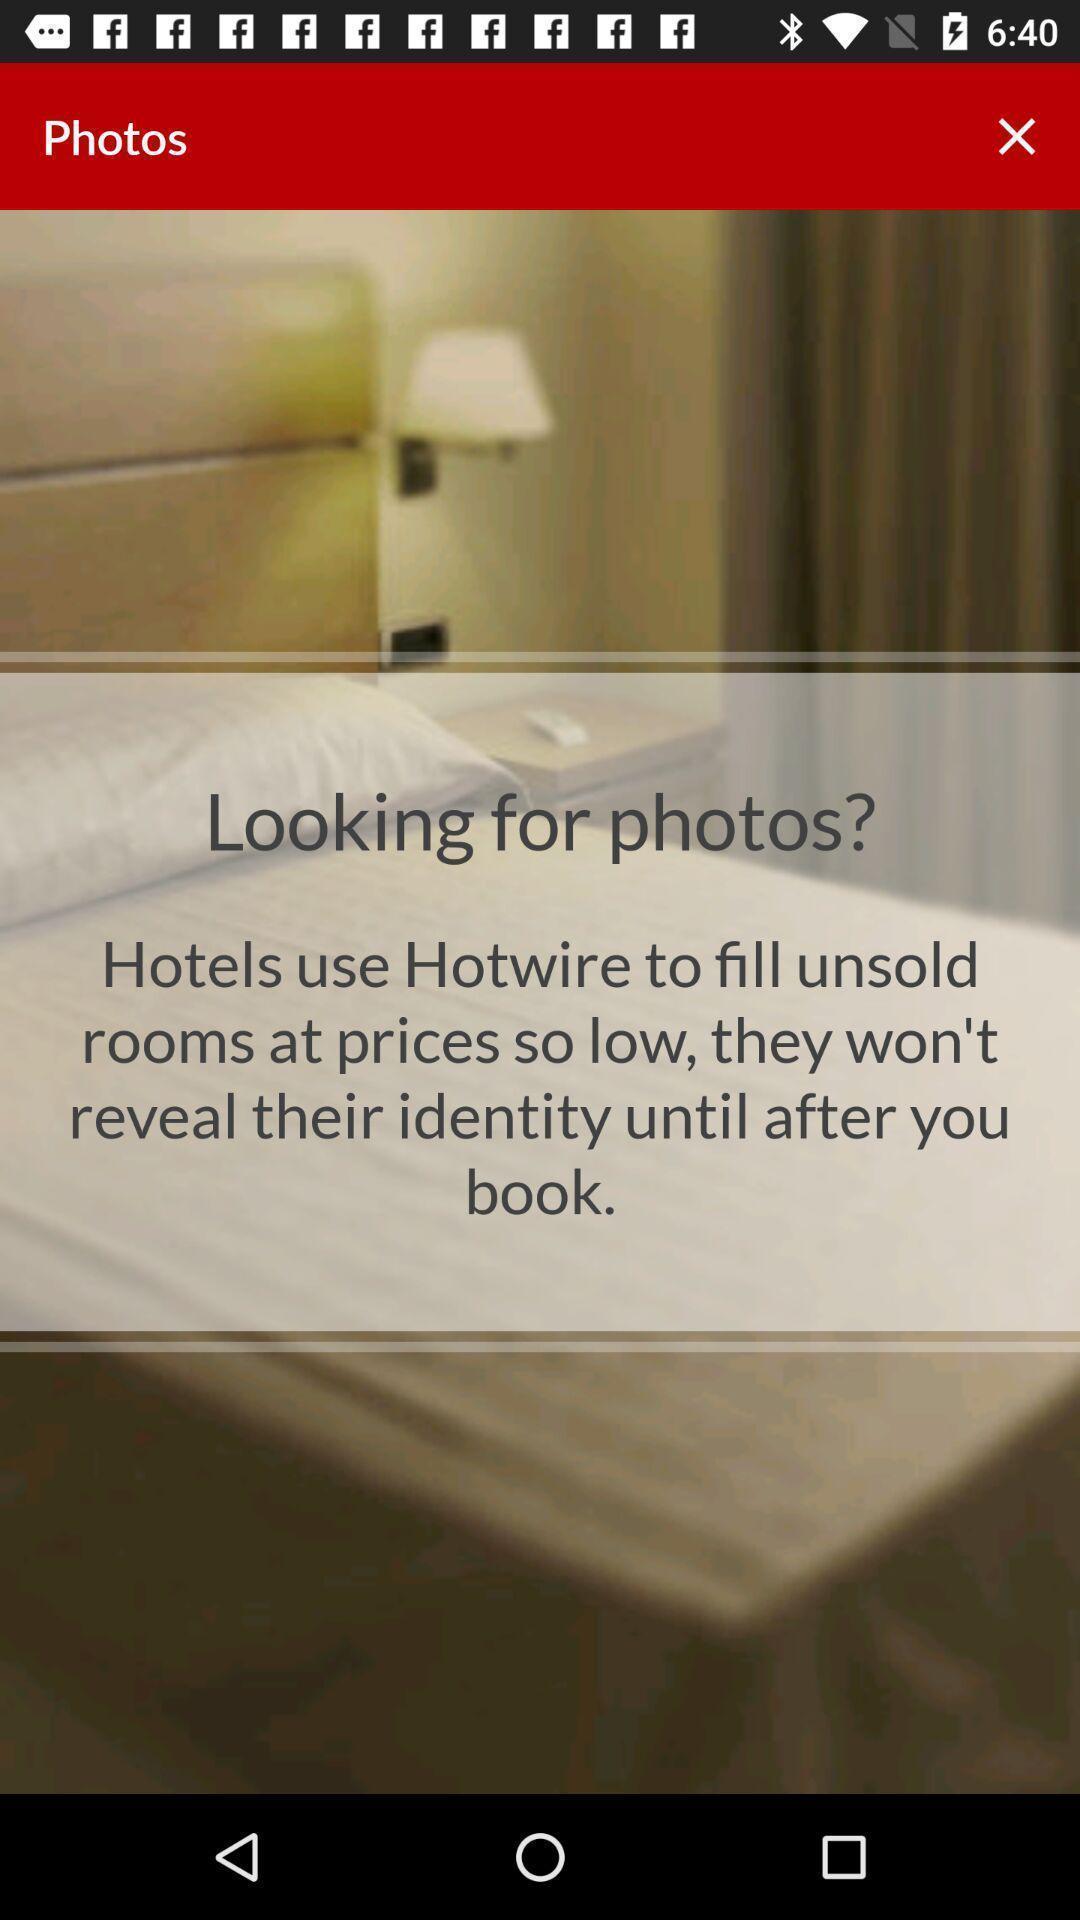Describe this image in words. Page displaying the image and comment looking for photos. 